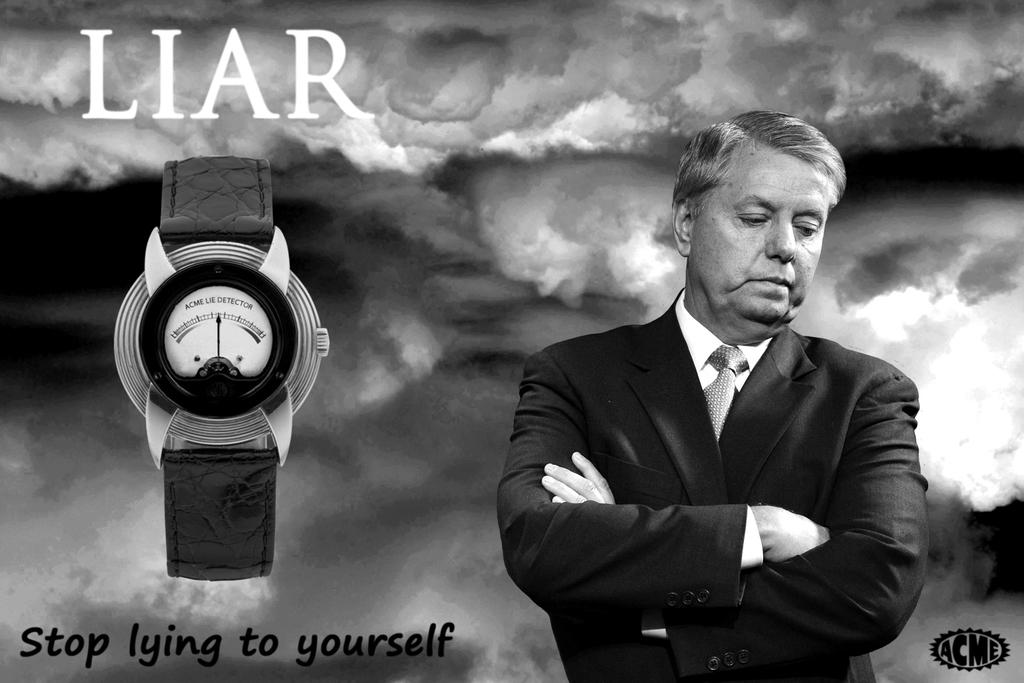What is the slogan for this watch?
Give a very brief answer. Stop lying to yourself. 